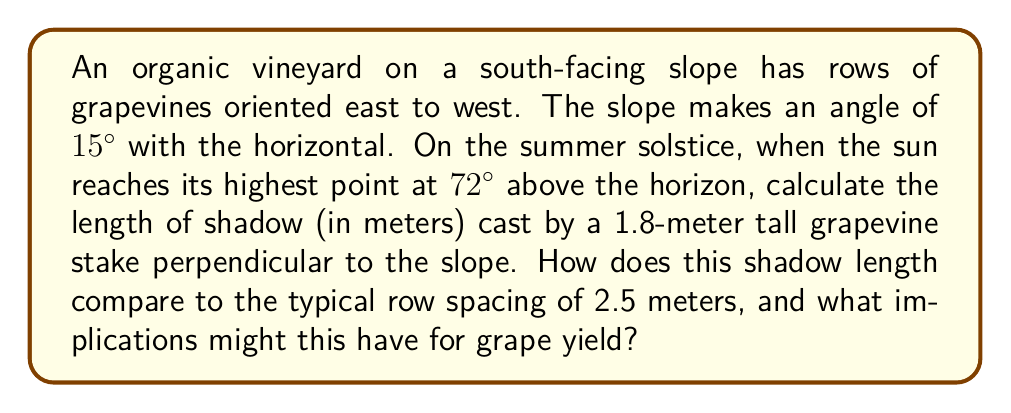Provide a solution to this math problem. Let's approach this problem step-by-step:

1) First, we need to find the angle between the sun's rays and the slope. We can do this by subtracting the slope angle from the sun's angle above the horizon:
   $72° - 15° = 57°$

2) Now we have a right triangle where:
   - The hypotenuse is the sun's ray
   - The adjacent side is the shadow on the slope
   - The opposite side is the height of the stake perpendicular to the slope

3) We can use the tangent function to find the length of the shadow:

   $$\tan(57°) = \frac{\text{stake height}}{\text{shadow length}}$$

4) Rearranging this equation:

   $$\text{shadow length} = \frac{\text{stake height}}{\tan(57°)}$$

5) Plugging in the values:

   $$\text{shadow length} = \frac{1.8 \text{ m}}{\tan(57°)} \approx 1.13 \text{ m}$$

6) Comparing to the typical row spacing:
   The shadow length (1.13 m) is less than half of the typical row spacing (2.5 m).

7) Implications for grape yield:
   - The shorter shadow means more direct sunlight reaches the lower parts of the vines and the ground between rows.
   - This increased sun exposure can lead to:
     a) Higher photosynthesis rates, potentially increasing grape yield
     b) Warmer soil temperatures, which can accelerate grape ripening
     c) Reduced humidity around the grapes, potentially decreasing fungal disease risk
   - However, in very hot climates, this level of exposure might risk sun damage to the grapes.
Answer: Shadow length: 1.13 m. This is less than half the typical row spacing, potentially increasing yield through greater sun exposure, faster ripening, and reduced disease risk. 